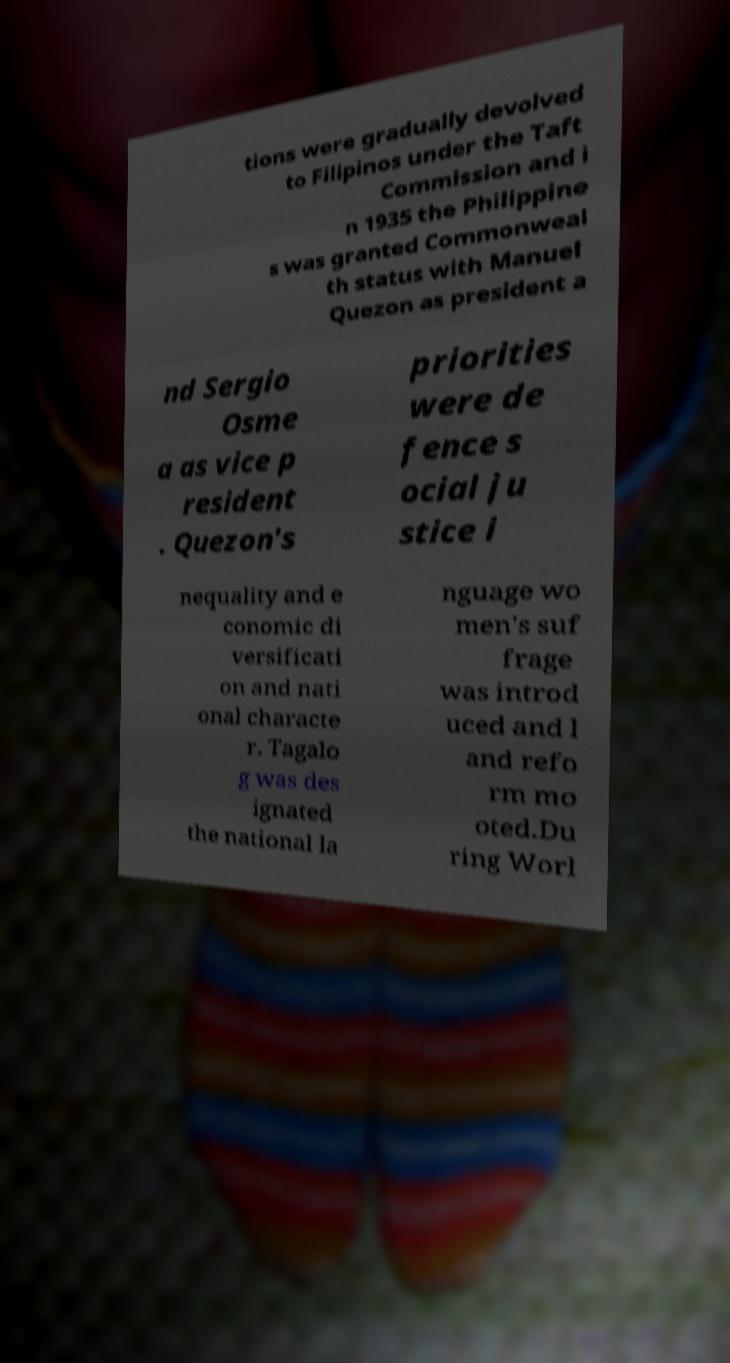Please identify and transcribe the text found in this image. tions were gradually devolved to Filipinos under the Taft Commission and i n 1935 the Philippine s was granted Commonweal th status with Manuel Quezon as president a nd Sergio Osme a as vice p resident . Quezon's priorities were de fence s ocial ju stice i nequality and e conomic di versificati on and nati onal characte r. Tagalo g was des ignated the national la nguage wo men's suf frage was introd uced and l and refo rm mo oted.Du ring Worl 